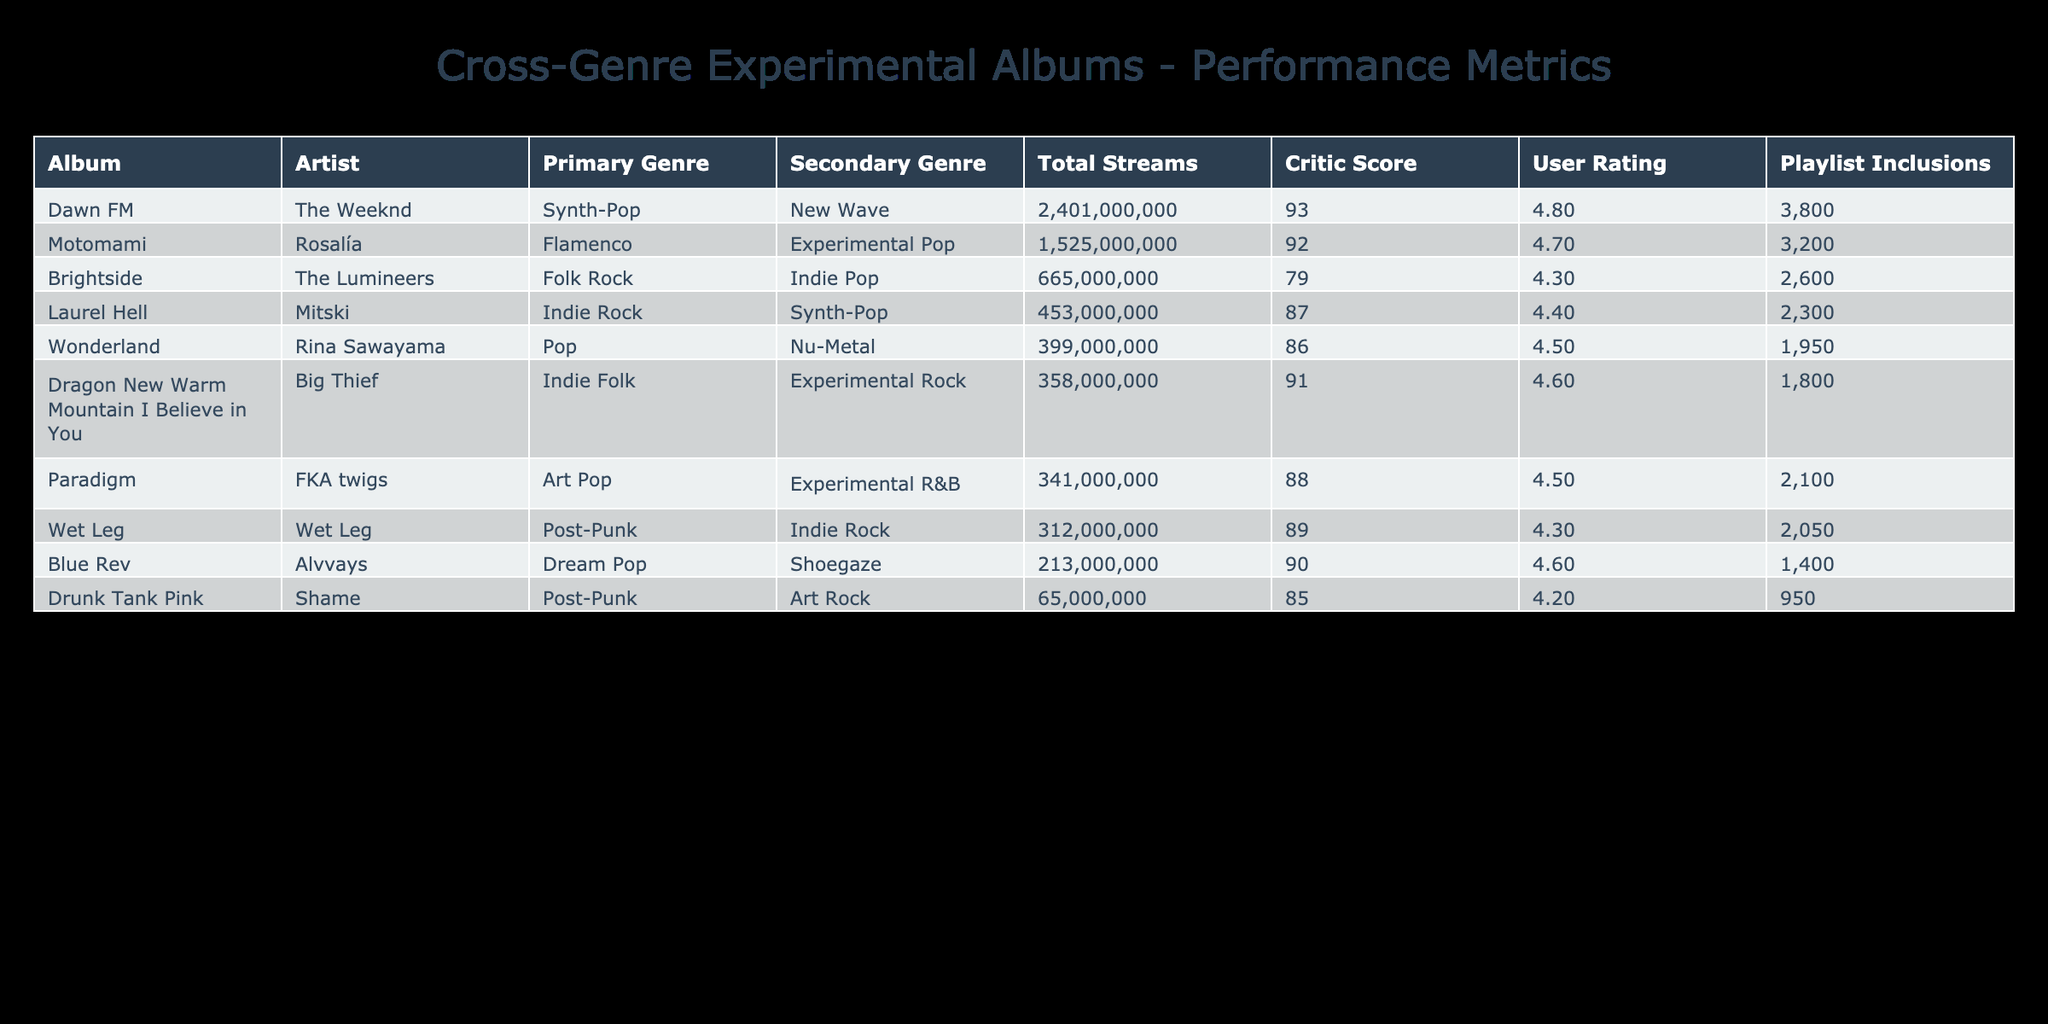What is the total number of streams for "Dawn FM"? The total number of streams is calculated by summing the Spotify Streams, Apple Music Streams, and YouTube Views. For "Dawn FM", the values are 1200000000 (Spotify) + 678000000 (Apple Music) + 523000000 (YouTube) which equals 2401000000.
Answer: 2401000000 Which album has the highest critic score? By examining the Critic Score column, "Motomami" has the highest score of 92.
Answer: Motomami How many playlist inclusions does "Dragon New Warm Mountain I Believe in You" have compared to "Paradigm"? "Dragon New Warm Mountain I Believe in You" has 1800 playlist inclusions, while "Paradigm" has 2100. The difference is 2100 - 1800 = 300.
Answer: 300 Is the User Rating for "Laurel Hell" higher than that for "Wet Leg"? "Laurel Hell" has a User Rating of 4.4, whereas "Wet Leg" has a User Rating of 4.3. Since 4.4 is greater than 4.3, yes, "Laurel Hell" has a higher User Rating.
Answer: Yes What is the total number of streams for albums from artists that have an Indie genre as Primary? The albums with Indie as Primary Genre are "Dragon New Warm Mountain I Believe in You" (201000000), "Laurel Hell" (245000000), and "Wet Leg" (167000000). Summing these gives 201000000 + 245000000 + 167000000 = 613000000.
Answer: 613000000 Which album has the least total streams? By looking at the Total Streams column after summing values for each album, "Drunk Tank Pink" has the least total streams at 60000000.
Answer: 60000000 What is the average User Rating for all albums listed? To find the average User Rating, sum the ratings (4.7 + 4.2 + 4.5 + 4.6 + 4.3 + 4.4 + 4.5 + 4.6 + 4.3 + 4.8) = 44.9 and divide by the total number of albums, which is 10. Therefore, 44.9 / 10 = 4.49.
Answer: 4.49 Does "Wonderland" have a higher critic score than "Brightside"? "Wonderland" has a critic score of 86, while "Brightside" has a critic score of 79. Since 86 is greater than 79, yes, "Wonderland" has a higher critic score.
Answer: Yes How many artists have a secondary genre listed as 'Pop'? The albums "Wonderland" (Rina Sawayama) and "Laurel Hell" (Mitski) have 'Pop' as a secondary genre. Therefore, there are 2 artists with 'Pop' as a secondary genre.
Answer: 2 